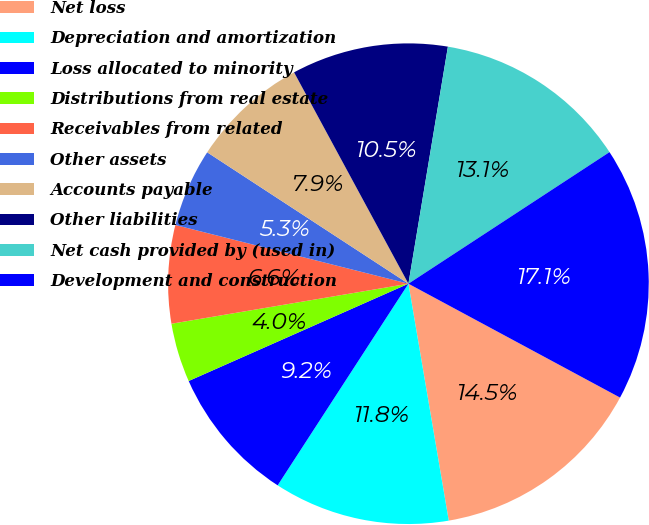<chart> <loc_0><loc_0><loc_500><loc_500><pie_chart><fcel>Net loss<fcel>Depreciation and amortization<fcel>Loss allocated to minority<fcel>Distributions from real estate<fcel>Receivables from related<fcel>Other assets<fcel>Accounts payable<fcel>Other liabilities<fcel>Net cash provided by (used in)<fcel>Development and construction<nl><fcel>14.46%<fcel>11.84%<fcel>9.21%<fcel>3.97%<fcel>6.59%<fcel>5.28%<fcel>7.9%<fcel>10.52%<fcel>13.15%<fcel>17.08%<nl></chart> 